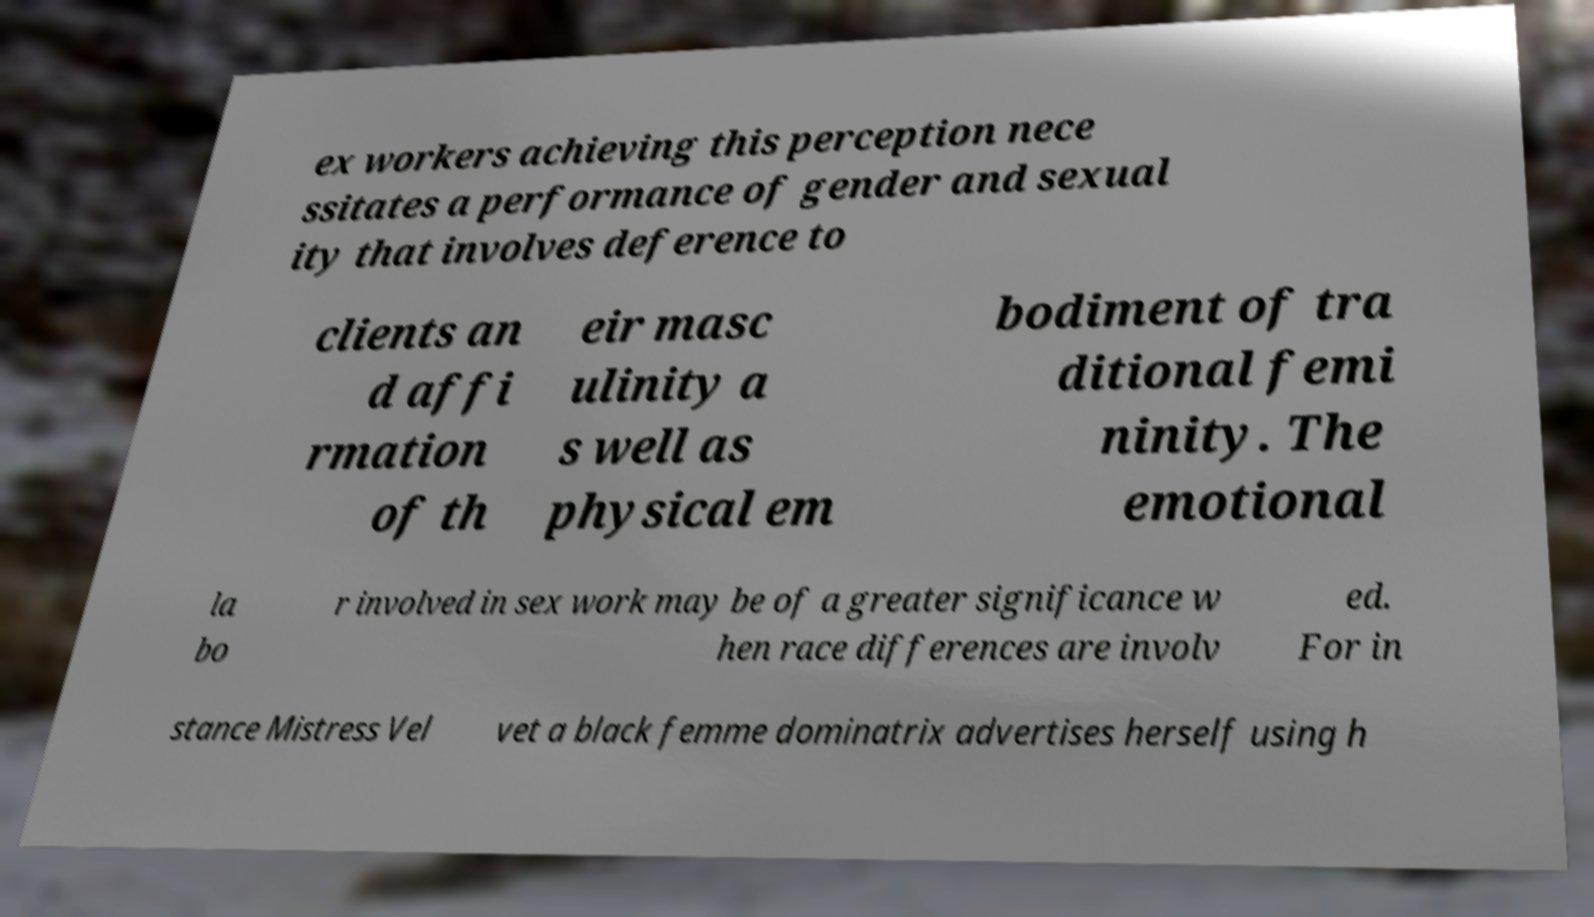Please identify and transcribe the text found in this image. ex workers achieving this perception nece ssitates a performance of gender and sexual ity that involves deference to clients an d affi rmation of th eir masc ulinity a s well as physical em bodiment of tra ditional femi ninity. The emotional la bo r involved in sex work may be of a greater significance w hen race differences are involv ed. For in stance Mistress Vel vet a black femme dominatrix advertises herself using h 